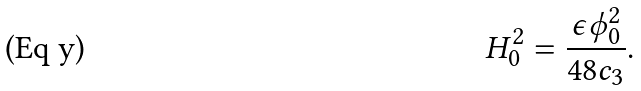Convert formula to latex. <formula><loc_0><loc_0><loc_500><loc_500>H _ { 0 } ^ { 2 } = { \frac { \epsilon \phi _ { 0 } ^ { 2 } } { 4 8 c _ { 3 } } } .</formula> 